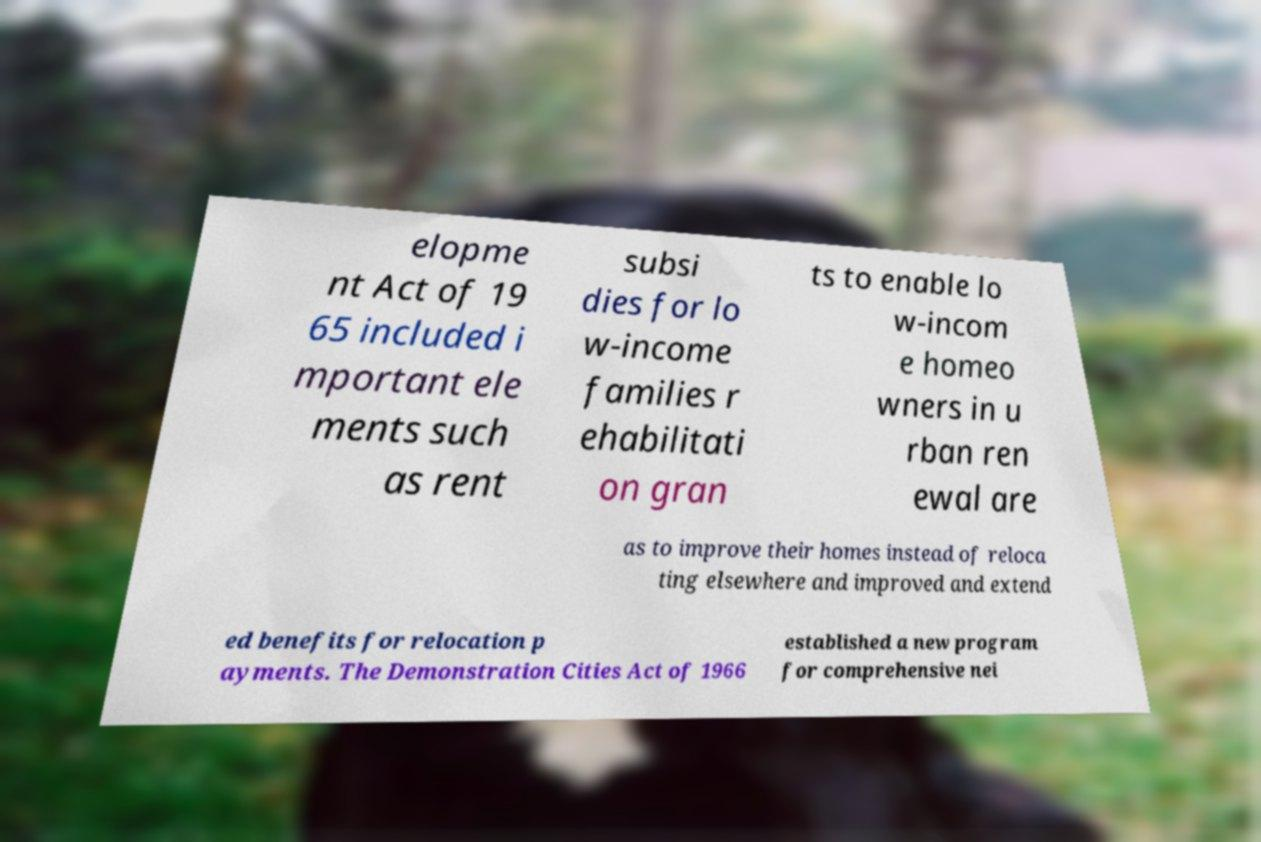What messages or text are displayed in this image? I need them in a readable, typed format. elopme nt Act of 19 65 included i mportant ele ments such as rent subsi dies for lo w-income families r ehabilitati on gran ts to enable lo w-incom e homeo wners in u rban ren ewal are as to improve their homes instead of reloca ting elsewhere and improved and extend ed benefits for relocation p ayments. The Demonstration Cities Act of 1966 established a new program for comprehensive nei 